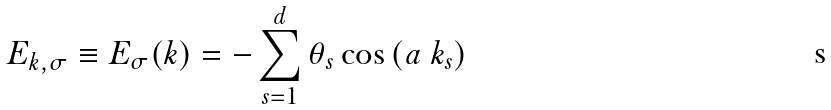<formula> <loc_0><loc_0><loc_500><loc_500>E _ { k , \sigma } \equiv E _ { \sigma } ( { k ) = - \sum _ { s = 1 } ^ { d } \theta _ { s } \cos \left ( a \ k _ { s } \right ) }</formula> 